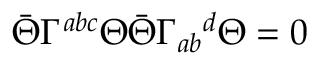Convert formula to latex. <formula><loc_0><loc_0><loc_500><loc_500>\bar { \Theta } \Gamma ^ { a b c } \Theta \bar { \Theta } \Gamma _ { a b ^ { d } \Theta = 0</formula> 